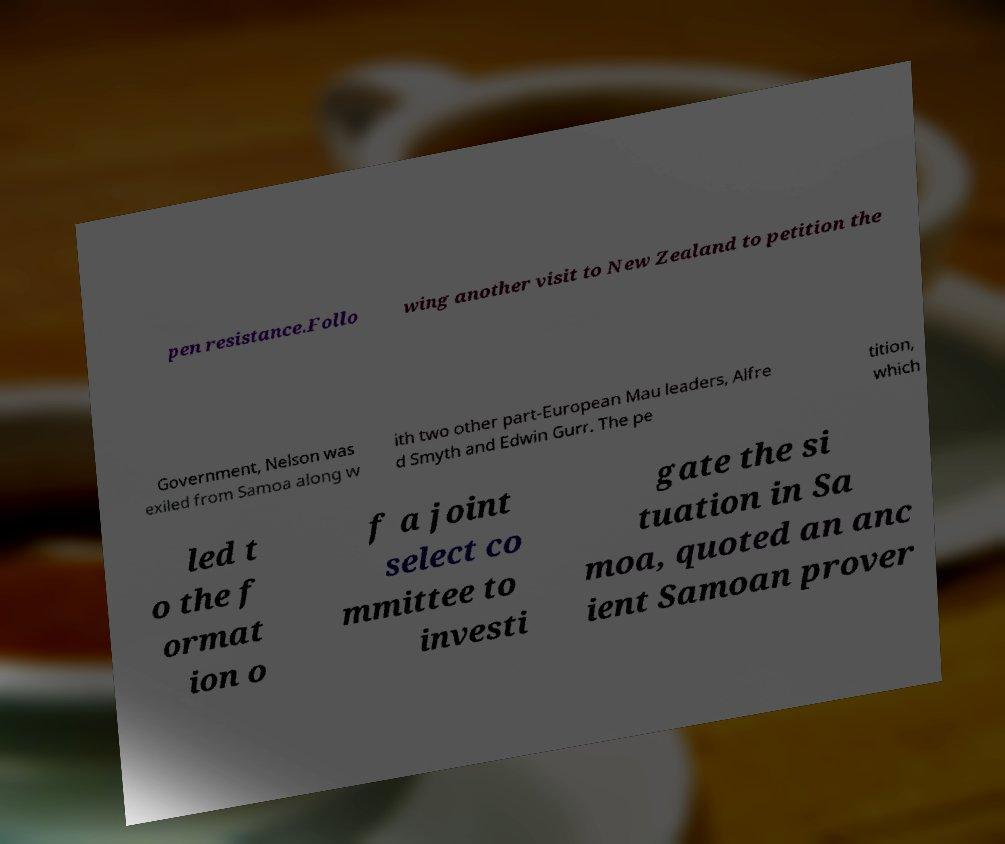Could you extract and type out the text from this image? pen resistance.Follo wing another visit to New Zealand to petition the Government, Nelson was exiled from Samoa along w ith two other part-European Mau leaders, Alfre d Smyth and Edwin Gurr. The pe tition, which led t o the f ormat ion o f a joint select co mmittee to investi gate the si tuation in Sa moa, quoted an anc ient Samoan prover 